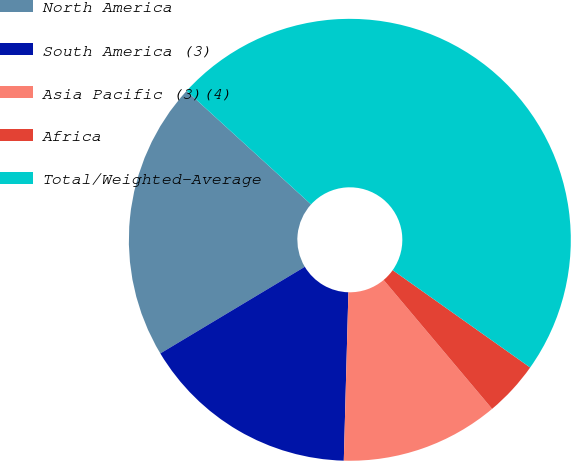Convert chart. <chart><loc_0><loc_0><loc_500><loc_500><pie_chart><fcel>North America<fcel>South America (3)<fcel>Asia Pacific (3)(4)<fcel>Africa<fcel>Total/Weighted-Average<nl><fcel>20.37%<fcel>15.97%<fcel>11.57%<fcel>4.06%<fcel>48.04%<nl></chart> 